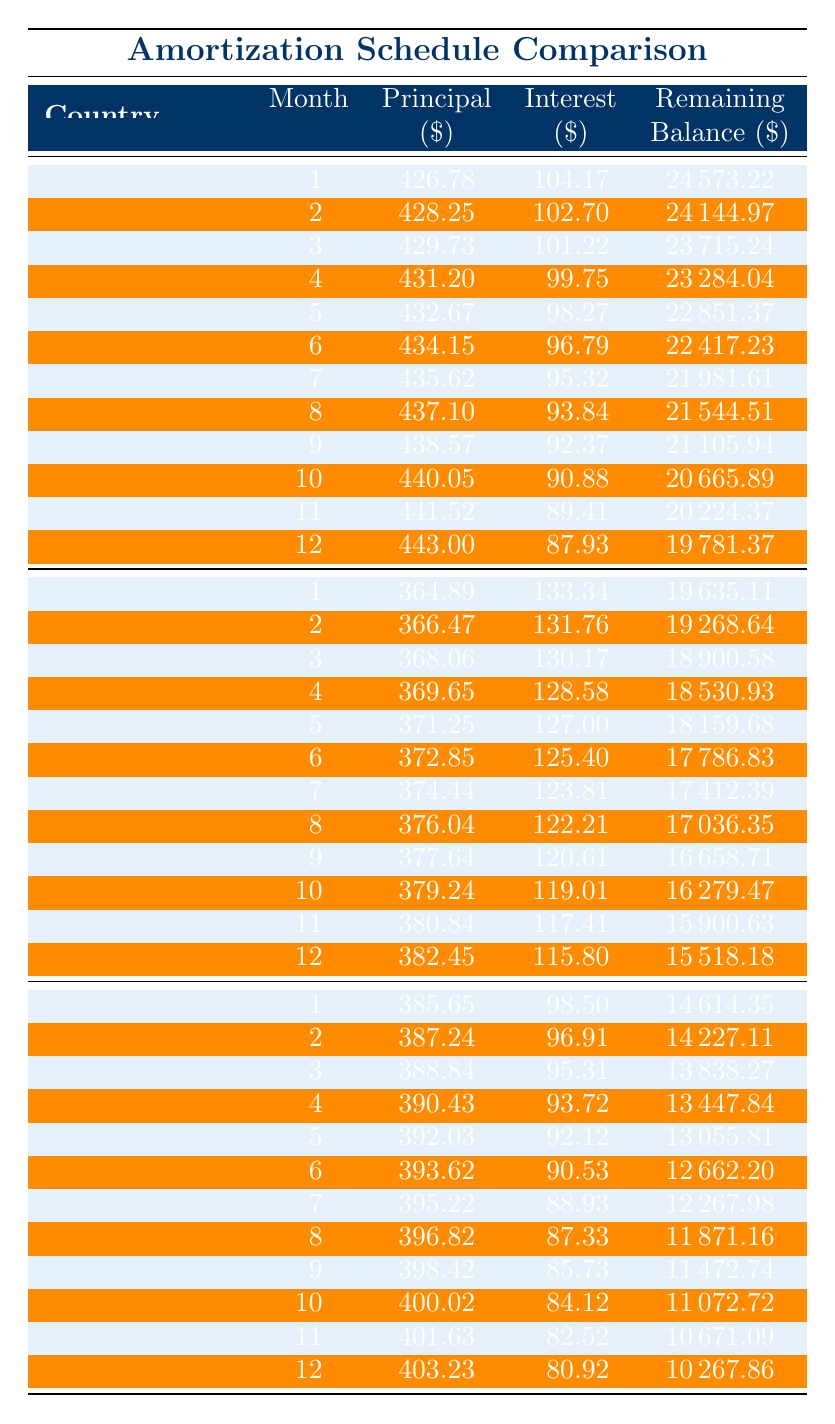What is the monthly payment amount for loans in Brazil? The table indicates the monthly payment for Brazil is listed in the row under its loan description, which shows 508.23.
Answer: 508.23 What is the total interest paid for the loan in the United States? According to the table, the total interest is specified for the United States row as 3306.62.
Answer: 3306.62 Which country has the lowest loan amount, and what is that amount? By comparing the loan amounts in the table, India has the lowest loan amount of 15000.
Answer: India, 15000 What is the average monthly payment for the three countries? To find the average, add the monthly payments: (471.78 + 508.23 + 484.15) = 1464.16, then divide by 3: 1464.16 / 3 = 488.72.
Answer: 488.72 Is the total payment higher in Brazil than in India? Yes, Brazil's total payment is 24394.51 while India's is 17490.15, which confirms Brazil has a higher total payment.
Answer: Yes What is the difference in total payment between the United States and Brazil? The total payment for the United States is 28306.62, while for Brazil it is 24394.51. The difference is calculated as 28306.62 - 24394.51 = 3901.11.
Answer: 3901.11 How much principal is paid off in the first month for India? Looking at the India row in the table, the principal paid off in the first month is noted as 385.65.
Answer: 385.65 What is the remaining balance after the 6th month in Brazil? Referring to the Brazil schedule, the remaining balance after the 6th month is shown as 17786.83.
Answer: 17786.83 Does the United States have a longer loan term than India? Yes, the United States has a loan term of 5 years while India has a term of 3 years, indicating the United States has a longer term.
Answer: Yes 